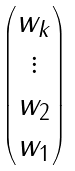<formula> <loc_0><loc_0><loc_500><loc_500>\begin{pmatrix} { w _ { k } } \\ { \vdots } \\ { w _ { 2 } } \\ { w _ { 1 } } \end{pmatrix}</formula> 